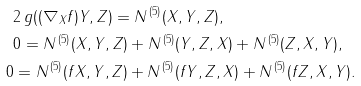<formula> <loc_0><loc_0><loc_500><loc_500>& 2 \, g ( ( \nabla _ { X } { f } ) Y , Z ) = N ^ { \, ( 5 ) } ( X , Y , Z ) , \\ & 0 = N ^ { \, ( 5 ) } ( X , Y , Z ) + N ^ { \, ( 5 ) } ( Y , Z , X ) + N ^ { \, ( 5 ) } ( Z , X , Y ) , \\ 0 & = N ^ { \, ( 5 ) } ( { f } X , Y , Z ) + N ^ { \, ( 5 ) } ( { f } Y , Z , X ) + N ^ { \, ( 5 ) } ( { f } Z , X , Y ) .</formula> 